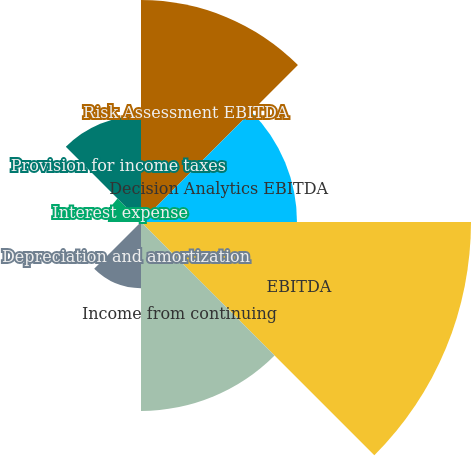Convert chart. <chart><loc_0><loc_0><loc_500><loc_500><pie_chart><fcel>Risk Assessment EBITDA<fcel>Decision Analytics EBITDA<fcel>EBITDA<fcel>Income from continuing<fcel>Depreciation and amortization<fcel>Investment income and realized<fcel>Interest expense<fcel>Provision for income taxes<nl><fcel>20.12%<fcel>14.14%<fcel>29.92%<fcel>17.13%<fcel>6.0%<fcel>0.02%<fcel>3.01%<fcel>9.64%<nl></chart> 